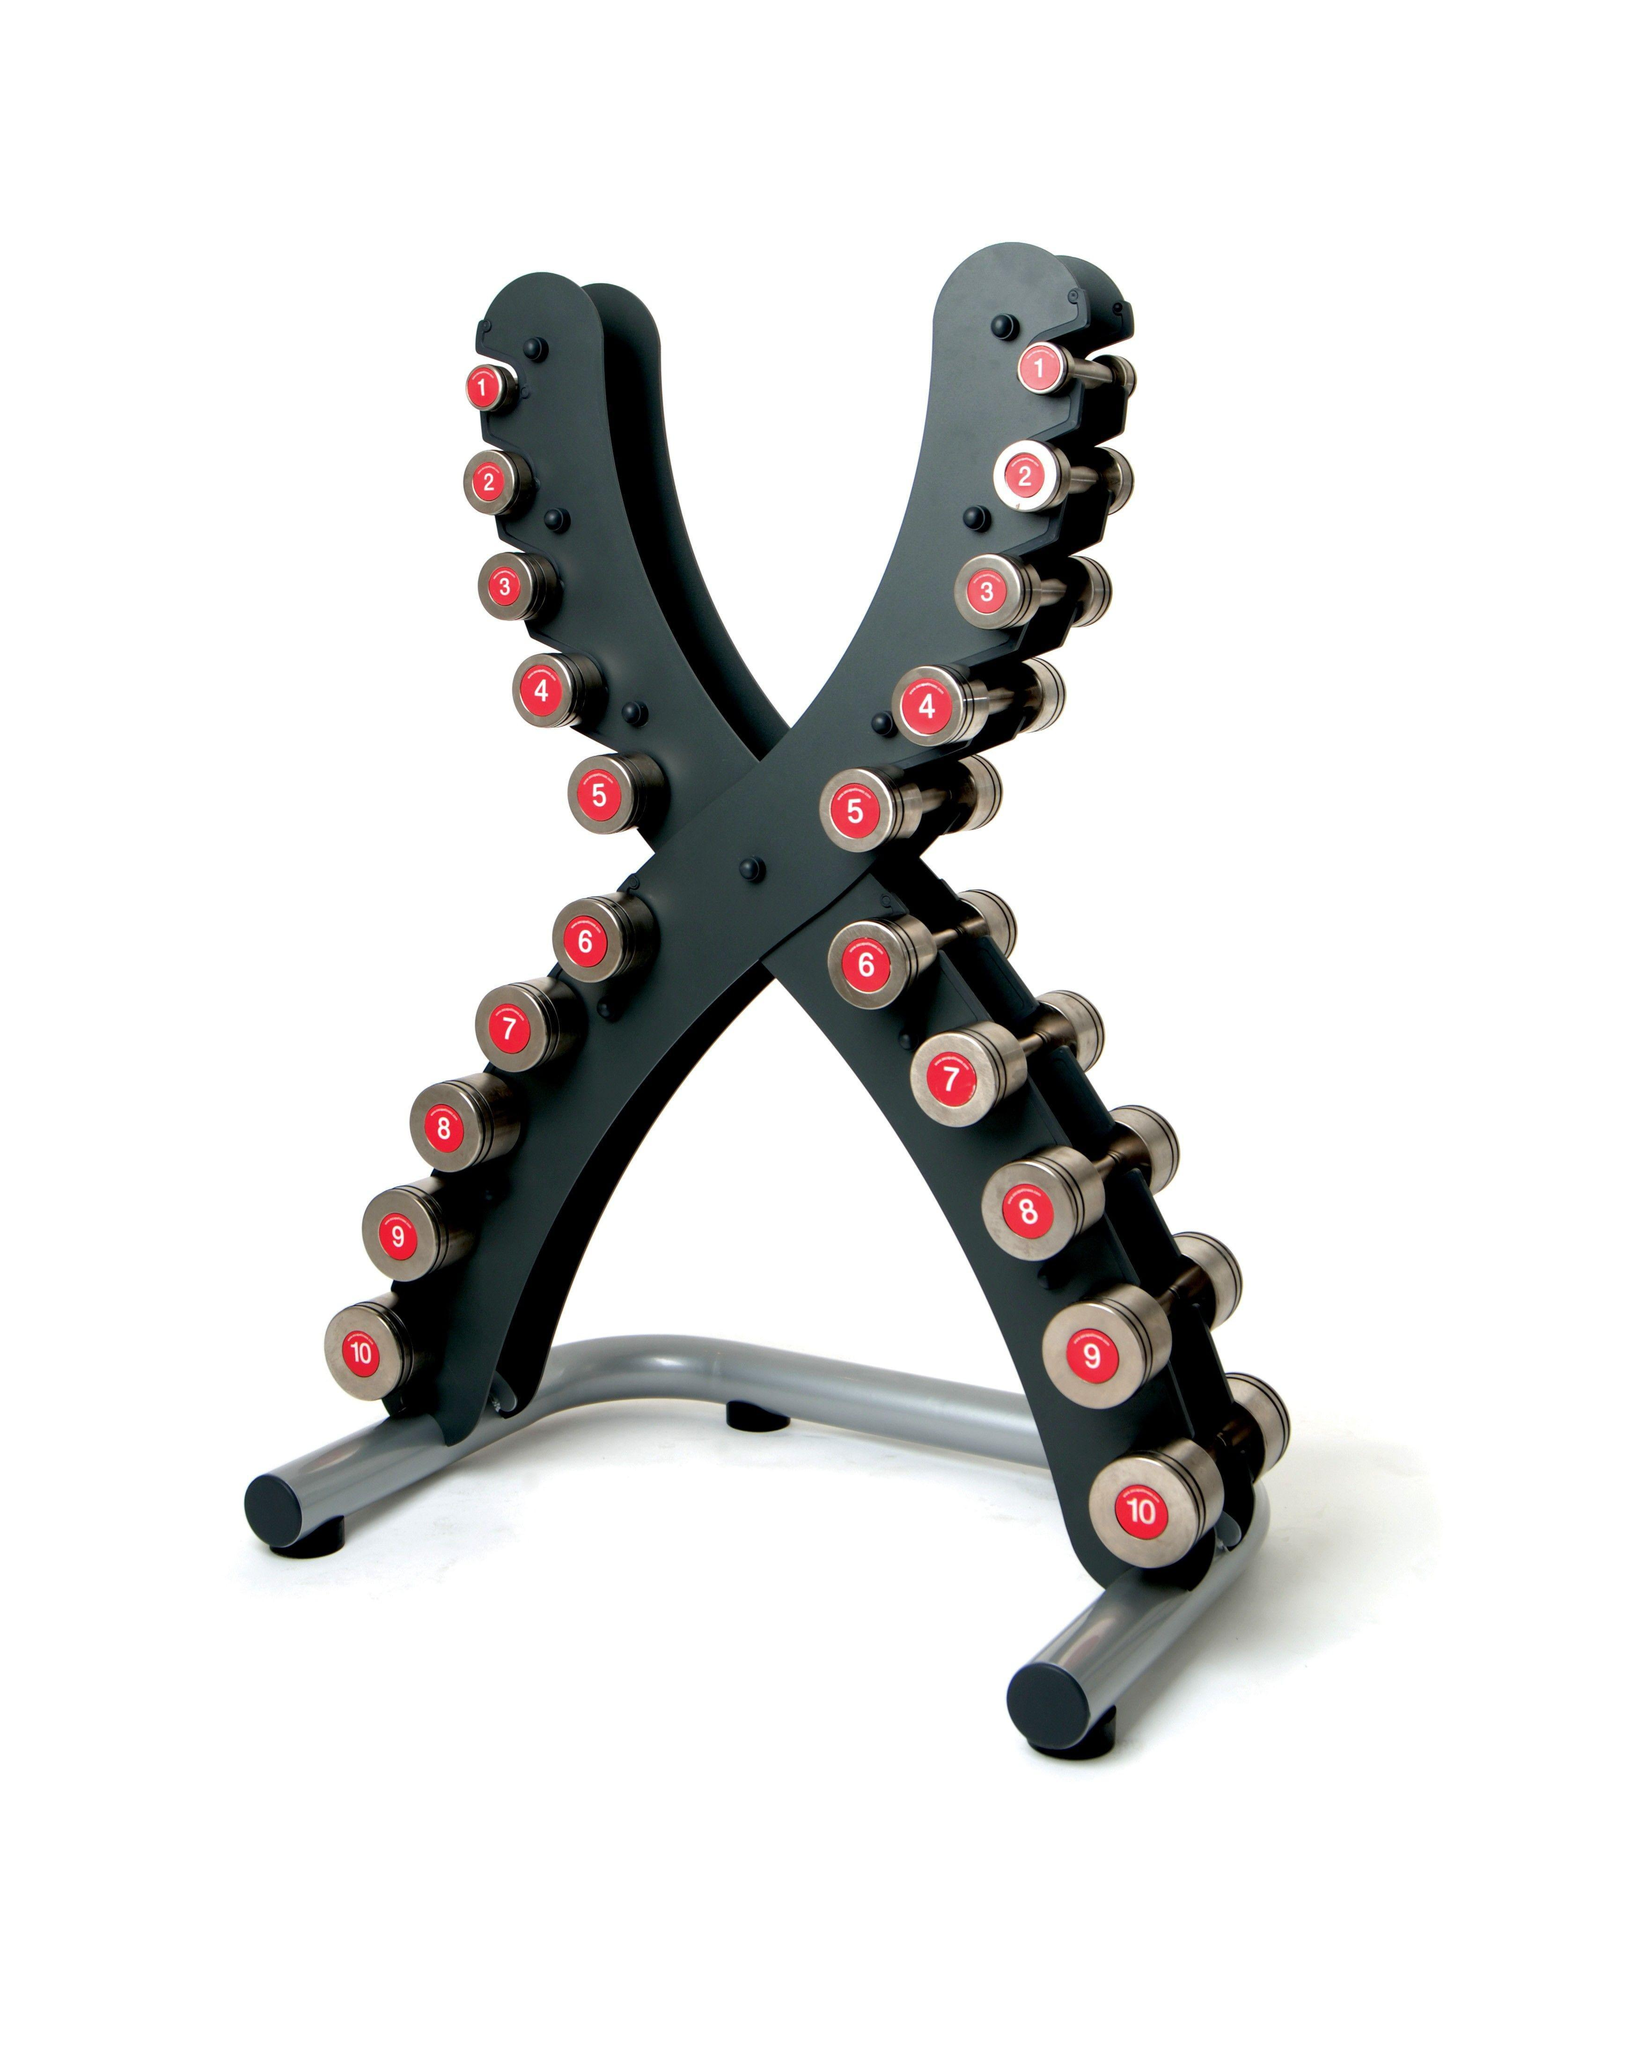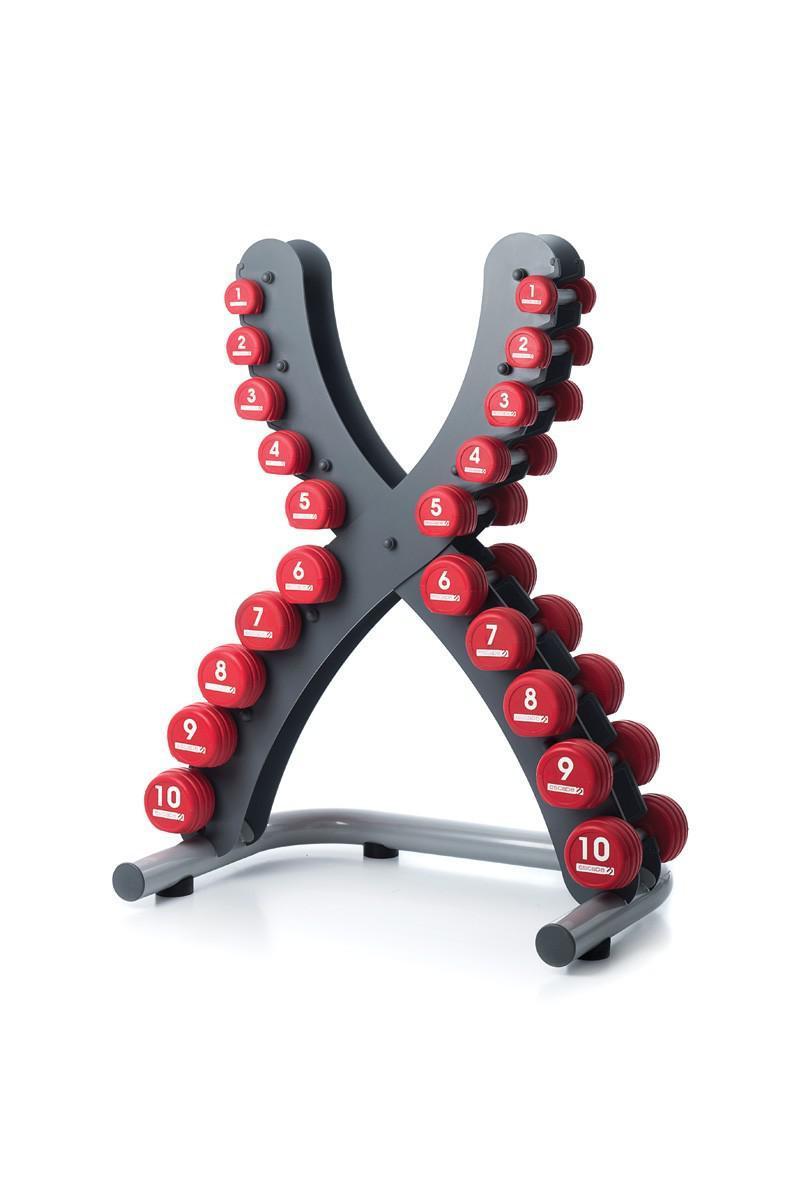The first image is the image on the left, the second image is the image on the right. For the images shown, is this caption "There are two triangular shaped racks of dumbells in the pair of images." true? Answer yes or no. No. The first image is the image on the left, the second image is the image on the right. For the images shown, is this caption "Two metal racks for weights are trangular shaped, one of them black with various colored weights, the other gray with black weights." true? Answer yes or no. No. 